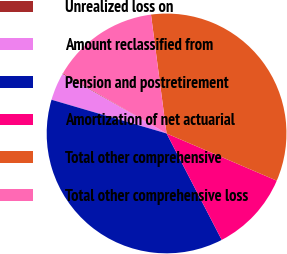Convert chart. <chart><loc_0><loc_0><loc_500><loc_500><pie_chart><fcel>Unrealized loss on<fcel>Amount reclassified from<fcel>Pension and postretirement<fcel>Amortization of net actuarial<fcel>Total other comprehensive<fcel>Total other comprehensive loss<nl><fcel>0.11%<fcel>3.72%<fcel>37.14%<fcel>10.95%<fcel>33.52%<fcel>14.56%<nl></chart> 